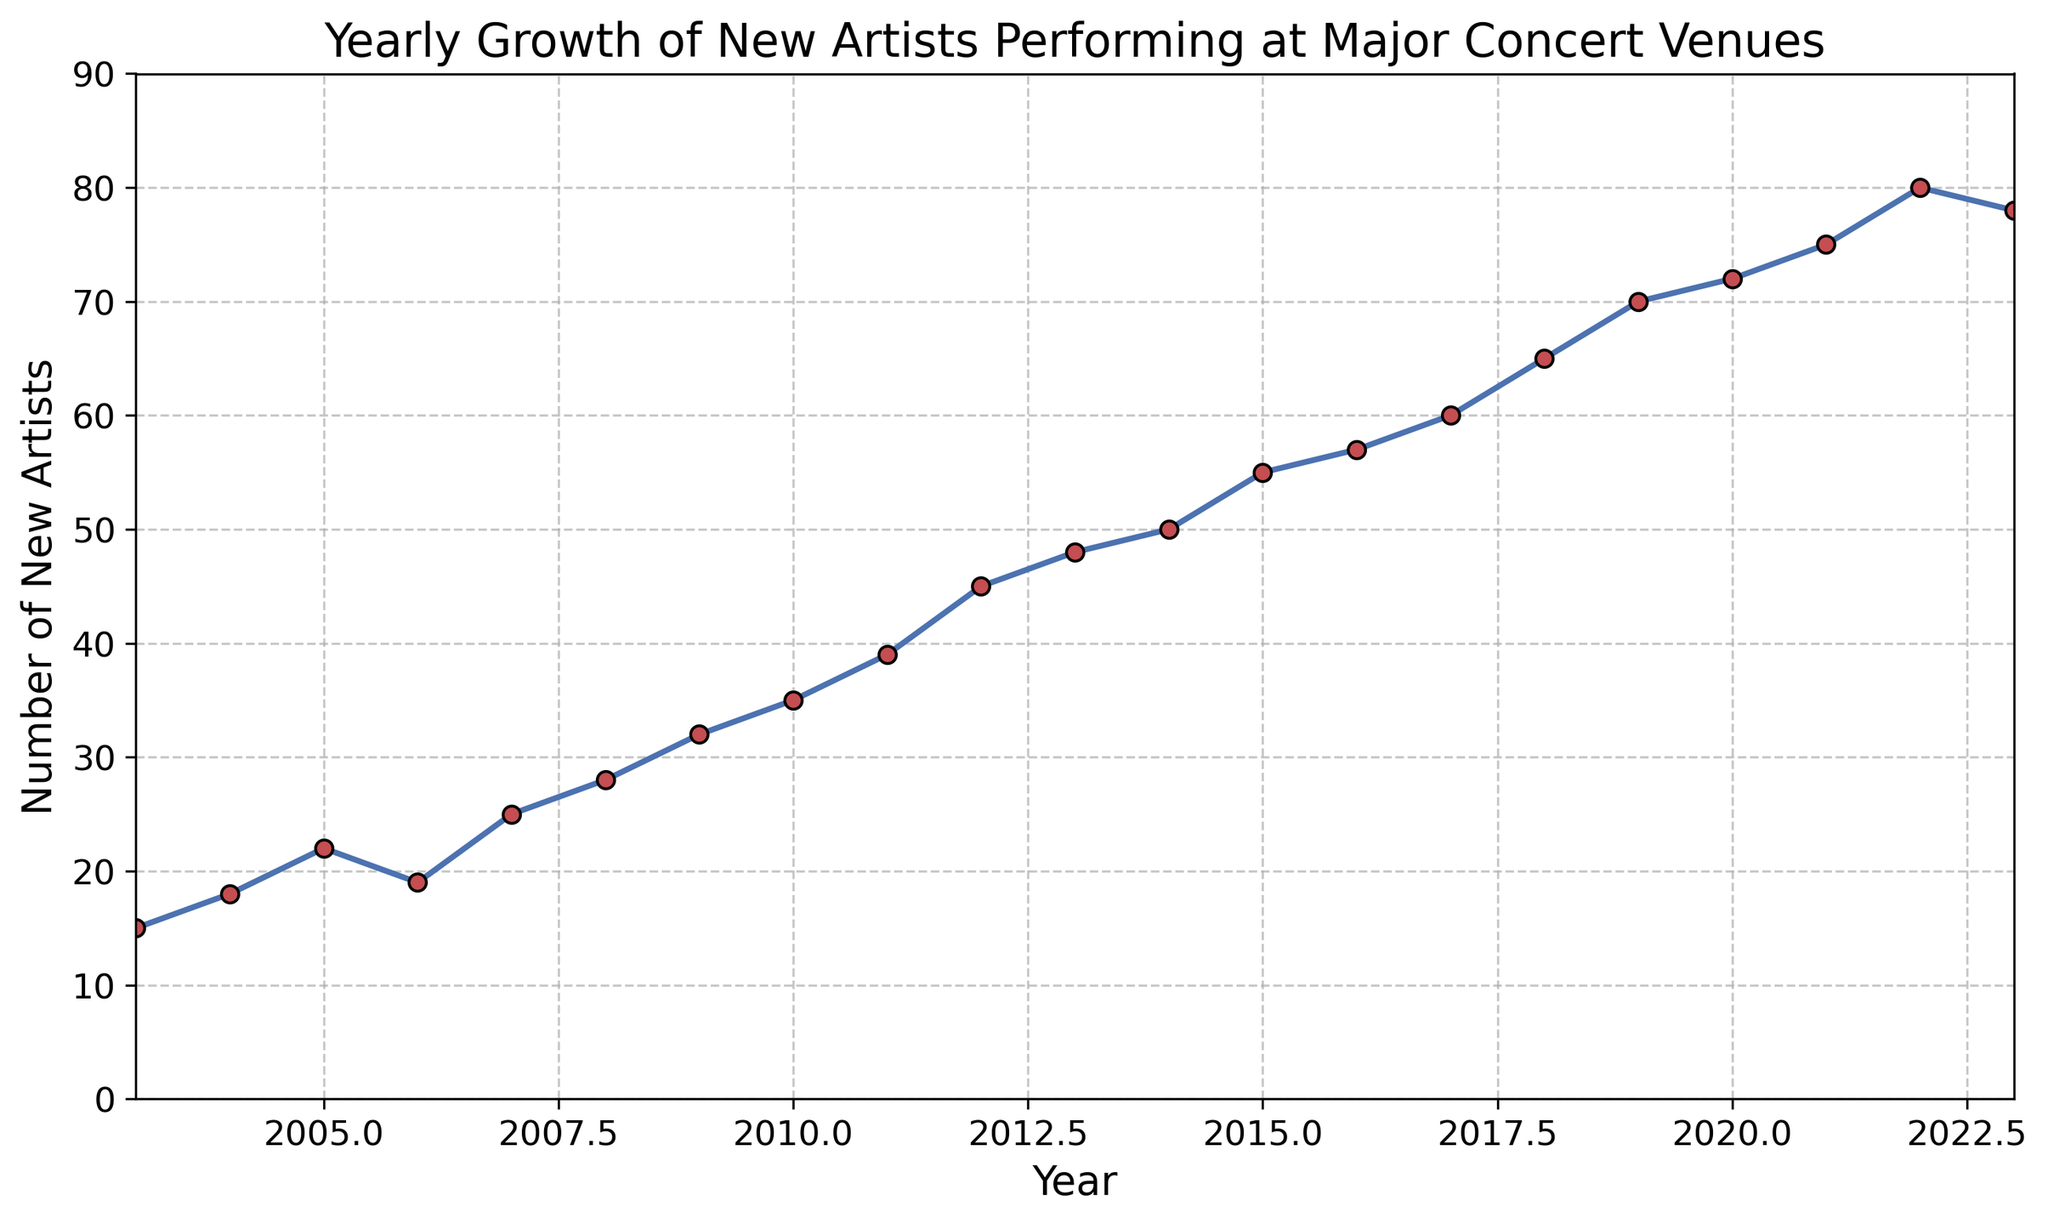What's the highest number of new artists performing in a single year? Looking at the data points on the line chart, the highest peak indicates the maximum number of new artists. In 2022, the number reached 80, the highest across the 20 years.
Answer: 80 Which year saw the largest increase in new artists compared to the previous year? To find the largest increase, calculate the differences between each consecutive year's data points. The biggest jump is from 2011 to 2012, which is 45 - 39 = 6.
Answer: 2012 In which year did the number of new artists first exceed 50? Looking across the x-axis from left to right, the first year where the y-value exceeds 50 is 2015.
Answer: 2015 What is the average number of new artists performing from 2003 to 2023? Calculate the sum of the new artists from all years and then divide by the number of years (21). The sum is 985, so the average is 985 / 21 ≈ 46.9.
Answer: 46.9 How does the number of new artists in 2023 compare to 2022? Compare the data points directly. In 2023, there are 78 new artists, and in 2022, there were 80. So, 2023 saw 2 fewer new artists.
Answer: 2 fewer During the 2008 financial crisis, did the number of new artists increase or decrease compared to the previous year? Observe the years around 2008; the number of new artists increased from 25 in 2007 to 28 in 2008.
Answer: Increase What is the overall trend in the number of new artists from 2003 to 2023? Examining the entire line from start to end, the general trend shows an upward trajectory, indicating growth over the 20 years.
Answer: Upward trend Which years show a decline in the number of new artists compared to the prior year? Identify where the line points downward: 2006 (22 to 19) and 2023 (80 to 78).
Answer: 2006 and 2023 On average, how many new artists performed each year between 2010 and 2020? Sum the values from 2010 to 2020 (35, 39, 45, 48, 50, 55, 57, 60, 65, 70, 72) and divide by the number of years (11). The sum is 596, so the average is 596 / 11 ≈ 54.2.
Answer: 54.2 What is the median number of new artists performing across the 20 years? List all values in ascending order and find the middle value: the median is the average of the 10th and 11th data points (35 and 39), so (35 + 39) / 2 = 37.
Answer: 37 